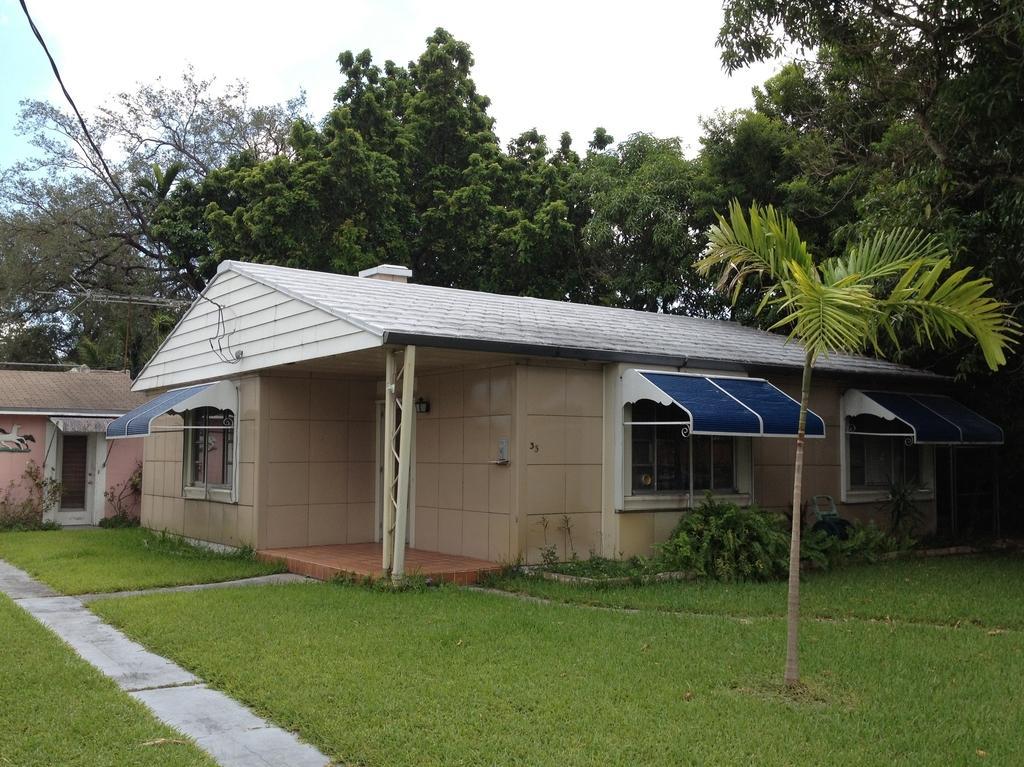Describe this image in one or two sentences. In this image I can see the grass. I can see the houses. In the background, I can see the trees and the sky. 